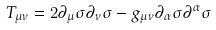Convert formula to latex. <formula><loc_0><loc_0><loc_500><loc_500>T _ { \mu \nu } = 2 \partial _ { \mu } \sigma \partial _ { \nu } \sigma - g _ { \mu \nu } \partial _ { \alpha } \sigma \partial ^ { \alpha } \sigma</formula> 